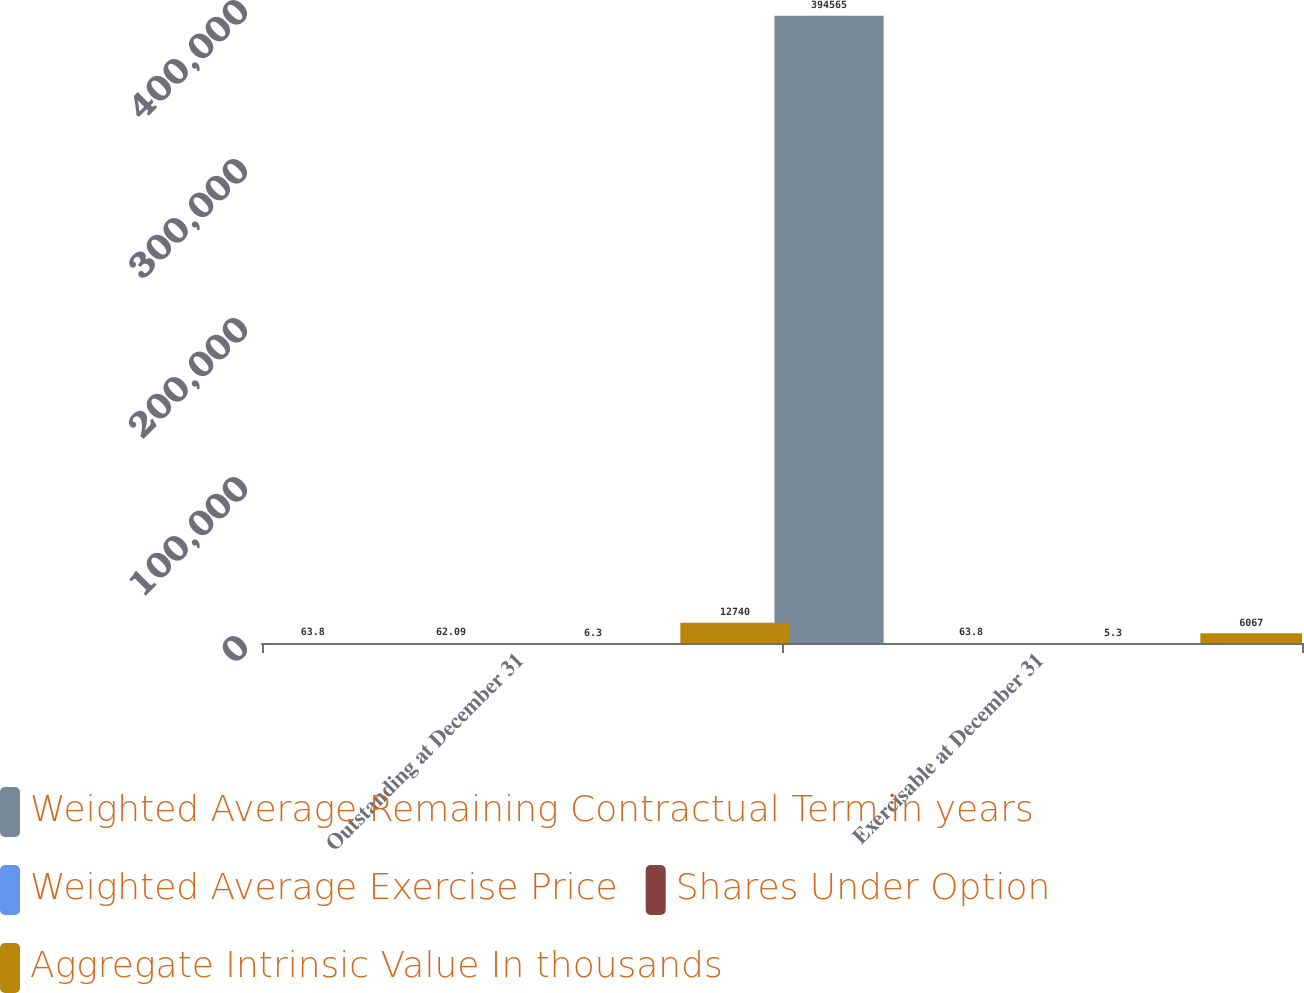<chart> <loc_0><loc_0><loc_500><loc_500><stacked_bar_chart><ecel><fcel>Outstanding at December 31<fcel>Exercisable at December 31<nl><fcel>Weighted Average Remaining Contractual Term In years<fcel>63.8<fcel>394565<nl><fcel>Weighted Average Exercise Price<fcel>62.09<fcel>63.8<nl><fcel>Shares Under Option<fcel>6.3<fcel>5.3<nl><fcel>Aggregate Intrinsic Value In thousands<fcel>12740<fcel>6067<nl></chart> 